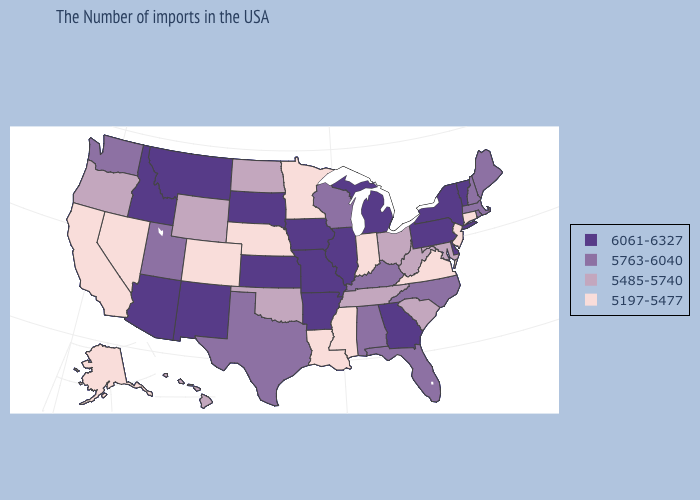Which states hav the highest value in the West?
Give a very brief answer. New Mexico, Montana, Arizona, Idaho. Does North Dakota have a lower value than Rhode Island?
Keep it brief. Yes. What is the lowest value in the Northeast?
Be succinct. 5197-5477. Does Alaska have the lowest value in the West?
Answer briefly. Yes. Which states have the highest value in the USA?
Keep it brief. Vermont, New York, Delaware, Pennsylvania, Georgia, Michigan, Illinois, Missouri, Arkansas, Iowa, Kansas, South Dakota, New Mexico, Montana, Arizona, Idaho. What is the value of Iowa?
Be succinct. 6061-6327. What is the value of Iowa?
Answer briefly. 6061-6327. What is the value of Maryland?
Be succinct. 5485-5740. Which states have the highest value in the USA?
Answer briefly. Vermont, New York, Delaware, Pennsylvania, Georgia, Michigan, Illinois, Missouri, Arkansas, Iowa, Kansas, South Dakota, New Mexico, Montana, Arizona, Idaho. What is the lowest value in states that border Montana?
Concise answer only. 5485-5740. Does North Dakota have the lowest value in the MidWest?
Concise answer only. No. What is the value of North Dakota?
Answer briefly. 5485-5740. Does Idaho have the same value as Arizona?
Keep it brief. Yes. Name the states that have a value in the range 5763-6040?
Be succinct. Maine, Massachusetts, Rhode Island, New Hampshire, North Carolina, Florida, Kentucky, Alabama, Wisconsin, Texas, Utah, Washington. What is the value of West Virginia?
Answer briefly. 5485-5740. 